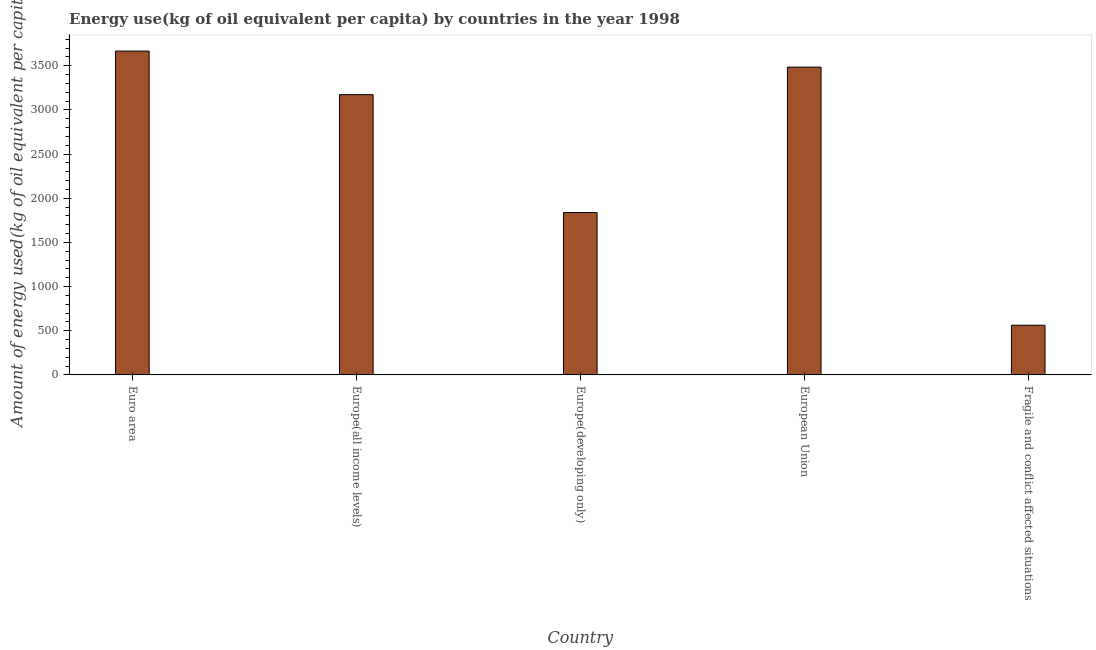Does the graph contain any zero values?
Provide a short and direct response. No. What is the title of the graph?
Make the answer very short. Energy use(kg of oil equivalent per capita) by countries in the year 1998. What is the label or title of the Y-axis?
Your answer should be very brief. Amount of energy used(kg of oil equivalent per capita). What is the amount of energy used in Euro area?
Your response must be concise. 3666.97. Across all countries, what is the maximum amount of energy used?
Offer a terse response. 3666.97. Across all countries, what is the minimum amount of energy used?
Offer a very short reply. 562.35. In which country was the amount of energy used minimum?
Give a very brief answer. Fragile and conflict affected situations. What is the sum of the amount of energy used?
Make the answer very short. 1.27e+04. What is the difference between the amount of energy used in Europe(all income levels) and European Union?
Offer a terse response. -311.78. What is the average amount of energy used per country?
Your answer should be very brief. 2545.28. What is the median amount of energy used?
Your response must be concise. 3173.52. In how many countries, is the amount of energy used greater than 100 kg?
Offer a very short reply. 5. What is the ratio of the amount of energy used in Europe(all income levels) to that in Fragile and conflict affected situations?
Keep it short and to the point. 5.64. Is the amount of energy used in Euro area less than that in Fragile and conflict affected situations?
Give a very brief answer. No. Is the difference between the amount of energy used in Euro area and Europe(developing only) greater than the difference between any two countries?
Ensure brevity in your answer.  No. What is the difference between the highest and the second highest amount of energy used?
Provide a short and direct response. 181.67. What is the difference between the highest and the lowest amount of energy used?
Give a very brief answer. 3104.62. How many countries are there in the graph?
Provide a short and direct response. 5. What is the Amount of energy used(kg of oil equivalent per capita) in Euro area?
Offer a terse response. 3666.97. What is the Amount of energy used(kg of oil equivalent per capita) in Europe(all income levels)?
Give a very brief answer. 3173.52. What is the Amount of energy used(kg of oil equivalent per capita) in Europe(developing only)?
Offer a terse response. 1838.25. What is the Amount of energy used(kg of oil equivalent per capita) of European Union?
Give a very brief answer. 3485.3. What is the Amount of energy used(kg of oil equivalent per capita) in Fragile and conflict affected situations?
Offer a very short reply. 562.35. What is the difference between the Amount of energy used(kg of oil equivalent per capita) in Euro area and Europe(all income levels)?
Make the answer very short. 493.46. What is the difference between the Amount of energy used(kg of oil equivalent per capita) in Euro area and Europe(developing only)?
Provide a succinct answer. 1828.72. What is the difference between the Amount of energy used(kg of oil equivalent per capita) in Euro area and European Union?
Your answer should be compact. 181.67. What is the difference between the Amount of energy used(kg of oil equivalent per capita) in Euro area and Fragile and conflict affected situations?
Your answer should be compact. 3104.62. What is the difference between the Amount of energy used(kg of oil equivalent per capita) in Europe(all income levels) and Europe(developing only)?
Your answer should be compact. 1335.26. What is the difference between the Amount of energy used(kg of oil equivalent per capita) in Europe(all income levels) and European Union?
Give a very brief answer. -311.78. What is the difference between the Amount of energy used(kg of oil equivalent per capita) in Europe(all income levels) and Fragile and conflict affected situations?
Offer a terse response. 2611.16. What is the difference between the Amount of energy used(kg of oil equivalent per capita) in Europe(developing only) and European Union?
Your response must be concise. -1647.04. What is the difference between the Amount of energy used(kg of oil equivalent per capita) in Europe(developing only) and Fragile and conflict affected situations?
Provide a succinct answer. 1275.9. What is the difference between the Amount of energy used(kg of oil equivalent per capita) in European Union and Fragile and conflict affected situations?
Keep it short and to the point. 2922.95. What is the ratio of the Amount of energy used(kg of oil equivalent per capita) in Euro area to that in Europe(all income levels)?
Your answer should be compact. 1.16. What is the ratio of the Amount of energy used(kg of oil equivalent per capita) in Euro area to that in Europe(developing only)?
Offer a terse response. 2. What is the ratio of the Amount of energy used(kg of oil equivalent per capita) in Euro area to that in European Union?
Your answer should be very brief. 1.05. What is the ratio of the Amount of energy used(kg of oil equivalent per capita) in Euro area to that in Fragile and conflict affected situations?
Your answer should be very brief. 6.52. What is the ratio of the Amount of energy used(kg of oil equivalent per capita) in Europe(all income levels) to that in Europe(developing only)?
Offer a terse response. 1.73. What is the ratio of the Amount of energy used(kg of oil equivalent per capita) in Europe(all income levels) to that in European Union?
Your response must be concise. 0.91. What is the ratio of the Amount of energy used(kg of oil equivalent per capita) in Europe(all income levels) to that in Fragile and conflict affected situations?
Keep it short and to the point. 5.64. What is the ratio of the Amount of energy used(kg of oil equivalent per capita) in Europe(developing only) to that in European Union?
Provide a short and direct response. 0.53. What is the ratio of the Amount of energy used(kg of oil equivalent per capita) in Europe(developing only) to that in Fragile and conflict affected situations?
Give a very brief answer. 3.27. What is the ratio of the Amount of energy used(kg of oil equivalent per capita) in European Union to that in Fragile and conflict affected situations?
Make the answer very short. 6.2. 